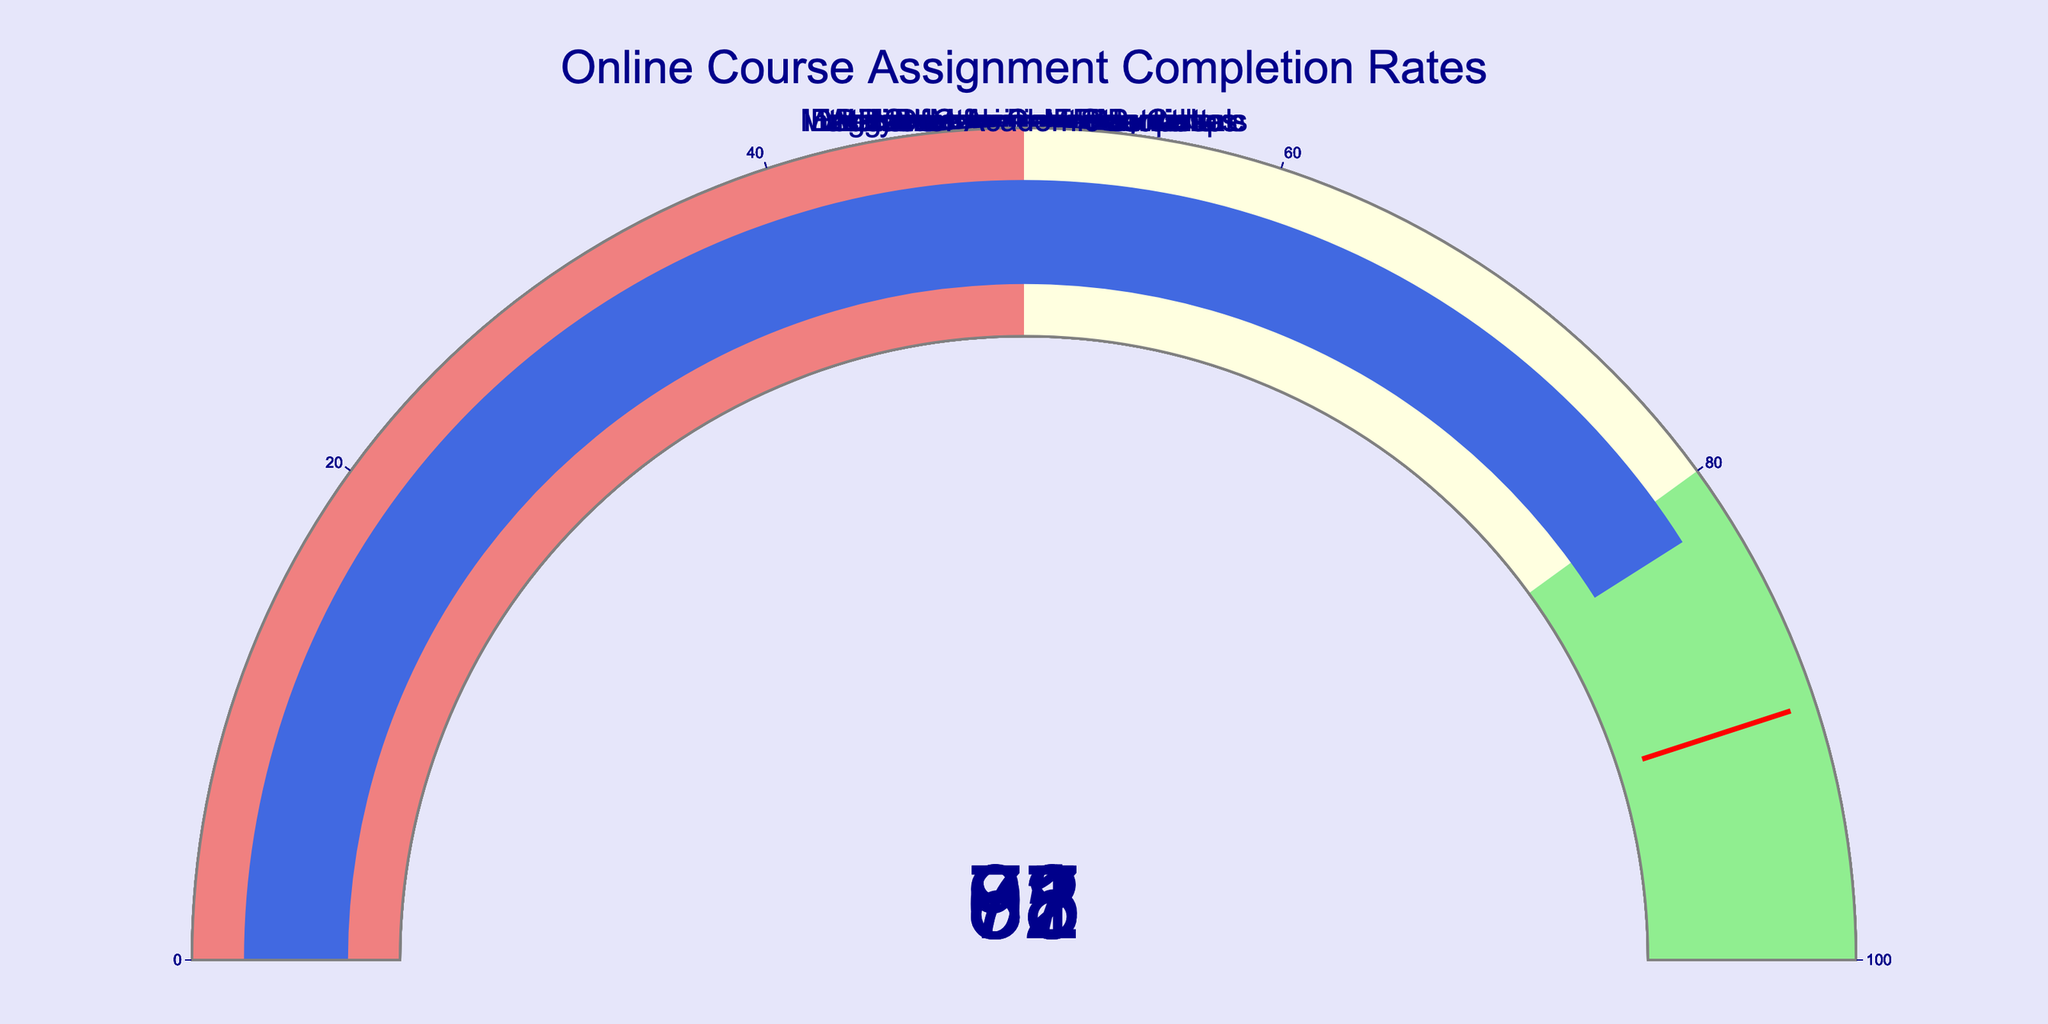What's the title of the figure? The title of the figure is located at the top center of the image, it combines the main topic and context of the visual data.
Answer: "Online Course Assignment Completion Rates" What is the completion rate for "Digital Marketing Essentials"? Look at the gauge chart labeled "Digital Marketing Essentials" and check the number shown on the gauge.
Answer: 63% Which course has the highest completion rate? Compare all the course completion rates displayed on the gauge charts and find the highest one.
Answer: "Indian Cuisine Masterclass" What is the average completion rate of all courses? Sum all the completion rates and divide by the number of courses: (78 + 92 + 85 + 63 + 71 + 97 + 88 + 82) / 8. First, calculate the total: 656. Then, divide by 8: 82.
Answer: 82% What is the difference between the completion rate of "Web Development Bootcamp" and "Machine Learning Fundamentals"? Subtract the completion rate of "Web Development Bootcamp" from "Machine Learning Fundamentals": 85 - 71.
Answer: 14% Which courses have completion rates exceeding the threshold of 90%? Identify the courses with completion rates greater than 90% from the gauges shown.
Answer: "Data Structures and Algorithms" and "Indian Cuisine Masterclass" Which course has the lowest completion rate? Find the course with the lowest value on the gauge charts.
Answer: "Digital Marketing Essentials" How many courses have a completion rate above 80%? Count the courses with completion rates displayed on the gauges that are more than 80%.
Answer: 5 What is the difference between the highest and lowest completion rates? Subtract the lowest completion rate from the highest completion rate: 97 - 63.
Answer: 34 How many courses fall within the range of 50% to 80% completion rate? Count the courses with completion rates displayed on the gauges that fall between (inclusive) 50% to 80%.
Answer: 4 